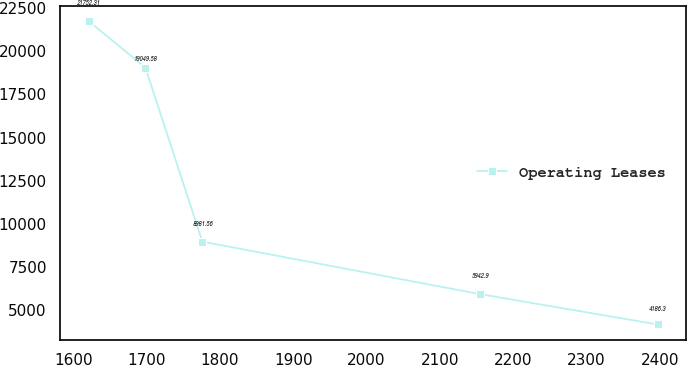Convert chart. <chart><loc_0><loc_0><loc_500><loc_500><line_chart><ecel><fcel>Operating Leases<nl><fcel>1620.94<fcel>21752.3<nl><fcel>1698.56<fcel>19049.6<nl><fcel>1776.17<fcel>8981.56<nl><fcel>2154.99<fcel>5942.9<nl><fcel>2397.09<fcel>4186.3<nl></chart> 